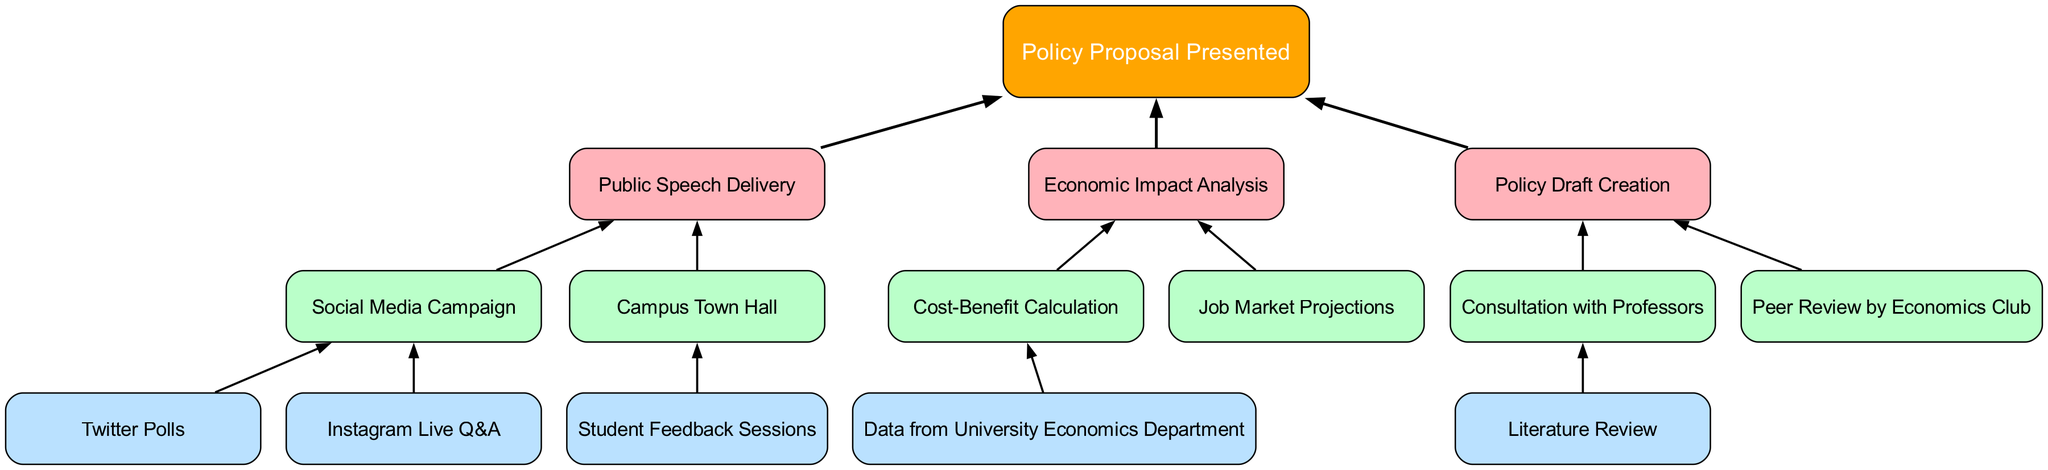What is the final node in the diagram? The final node is labeled "Policy Proposal Presented", which is the root of the diagram and indicates the end of the flow chart.
Answer: Policy Proposal Presented How many branches stem from the root node? The root node has three branches: "Public Speech Delivery", "Economic Impact Analysis", and "Policy Draft Creation". Counting them gives us three branches.
Answer: 3 What is the first child node under "Public Speech Delivery"? The first child node is "Social Media Campaign", which is the first of the two children directly linked to the "Public Speech Delivery" node.
Answer: Social Media Campaign Which node is associated with "Cost-Benefit Calculation"? The node "Cost-Benefit Calculation" is a child of "Economic Impact Analysis", making it directly associated with that node.
Answer: Economic Impact Analysis How many child nodes does "Policy Draft Creation" have? "Policy Draft Creation" has two child nodes: "Consultation with Professors" and "Peer Review by Economics Club". Therefore, it has a total of two child nodes.
Answer: 2 What connects "Instagram Live Q&A" to the rest of the diagram? "Instagram Live Q&A" is connected as a child of "Social Media Campaign", which is in turn a child of "Public Speech Delivery". So, it connects through two other nodes.
Answer: Social Media Campaign Are any child nodes under "Economic Impact Analysis" without further children? Yes, the "Job Market Projections" node does not have any further children, making it a terminal node under "Economic Impact Analysis".
Answer: Job Market Projections Which node requires consultation with professors? The node "Consultation with Professors" under "Policy Draft Creation" indicates that this step involves seeking input or guidance from professors.
Answer: Consultation with Professors What color is the node labeled "Economic Impact Analysis"? The "Economic Impact Analysis" node is colored with the first color from the defined color scheme, which is #FFB3BA.
Answer: #FFB3BA 